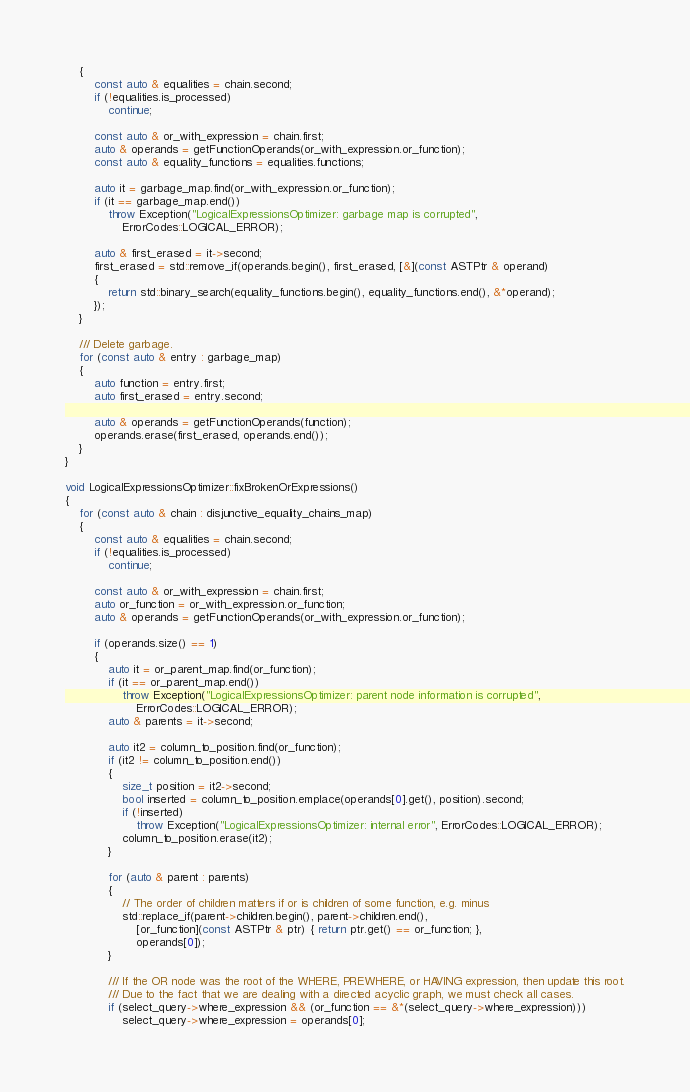<code> <loc_0><loc_0><loc_500><loc_500><_C++_>    {
        const auto & equalities = chain.second;
        if (!equalities.is_processed)
            continue;

        const auto & or_with_expression = chain.first;
        auto & operands = getFunctionOperands(or_with_expression.or_function);
        const auto & equality_functions = equalities.functions;

        auto it = garbage_map.find(or_with_expression.or_function);
        if (it == garbage_map.end())
            throw Exception("LogicalExpressionsOptimizer: garbage map is corrupted",
                ErrorCodes::LOGICAL_ERROR);

        auto & first_erased = it->second;
        first_erased = std::remove_if(operands.begin(), first_erased, [&](const ASTPtr & operand)
        {
            return std::binary_search(equality_functions.begin(), equality_functions.end(), &*operand);
        });
    }

    /// Delete garbage.
    for (const auto & entry : garbage_map)
    {
        auto function = entry.first;
        auto first_erased = entry.second;

        auto & operands = getFunctionOperands(function);
        operands.erase(first_erased, operands.end());
    }
}

void LogicalExpressionsOptimizer::fixBrokenOrExpressions()
{
    for (const auto & chain : disjunctive_equality_chains_map)
    {
        const auto & equalities = chain.second;
        if (!equalities.is_processed)
            continue;

        const auto & or_with_expression = chain.first;
        auto or_function = or_with_expression.or_function;
        auto & operands = getFunctionOperands(or_with_expression.or_function);

        if (operands.size() == 1)
        {
            auto it = or_parent_map.find(or_function);
            if (it == or_parent_map.end())
                throw Exception("LogicalExpressionsOptimizer: parent node information is corrupted",
                    ErrorCodes::LOGICAL_ERROR);
            auto & parents = it->second;

            auto it2 = column_to_position.find(or_function);
            if (it2 != column_to_position.end())
            {
                size_t position = it2->second;
                bool inserted = column_to_position.emplace(operands[0].get(), position).second;
                if (!inserted)
                    throw Exception("LogicalExpressionsOptimizer: internal error", ErrorCodes::LOGICAL_ERROR);
                column_to_position.erase(it2);
            }

            for (auto & parent : parents)
            {
                // The order of children matters if or is children of some function, e.g. minus
                std::replace_if(parent->children.begin(), parent->children.end(),
                    [or_function](const ASTPtr & ptr) { return ptr.get() == or_function; },
                    operands[0]);
            }

            /// If the OR node was the root of the WHERE, PREWHERE, or HAVING expression, then update this root.
            /// Due to the fact that we are dealing with a directed acyclic graph, we must check all cases.
            if (select_query->where_expression && (or_function == &*(select_query->where_expression)))
                select_query->where_expression = operands[0];</code> 